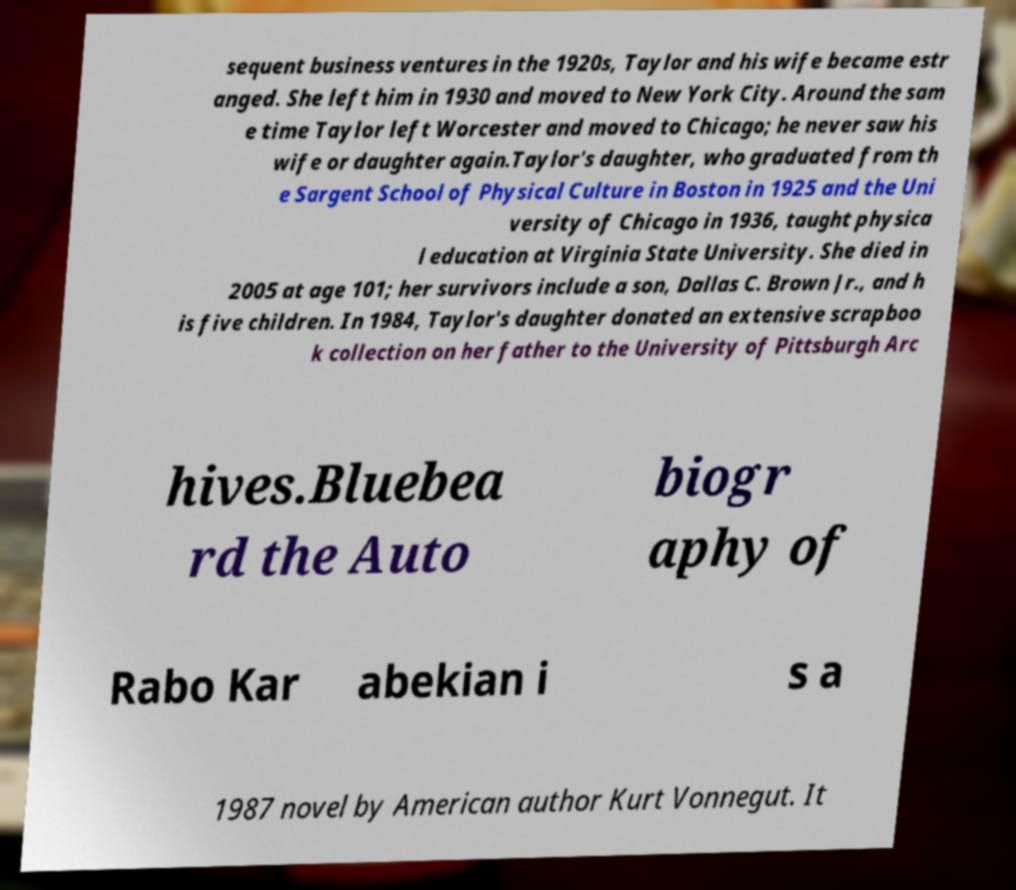Could you extract and type out the text from this image? sequent business ventures in the 1920s, Taylor and his wife became estr anged. She left him in 1930 and moved to New York City. Around the sam e time Taylor left Worcester and moved to Chicago; he never saw his wife or daughter again.Taylor's daughter, who graduated from th e Sargent School of Physical Culture in Boston in 1925 and the Uni versity of Chicago in 1936, taught physica l education at Virginia State University. She died in 2005 at age 101; her survivors include a son, Dallas C. Brown Jr., and h is five children. In 1984, Taylor's daughter donated an extensive scrapboo k collection on her father to the University of Pittsburgh Arc hives.Bluebea rd the Auto biogr aphy of Rabo Kar abekian i s a 1987 novel by American author Kurt Vonnegut. It 